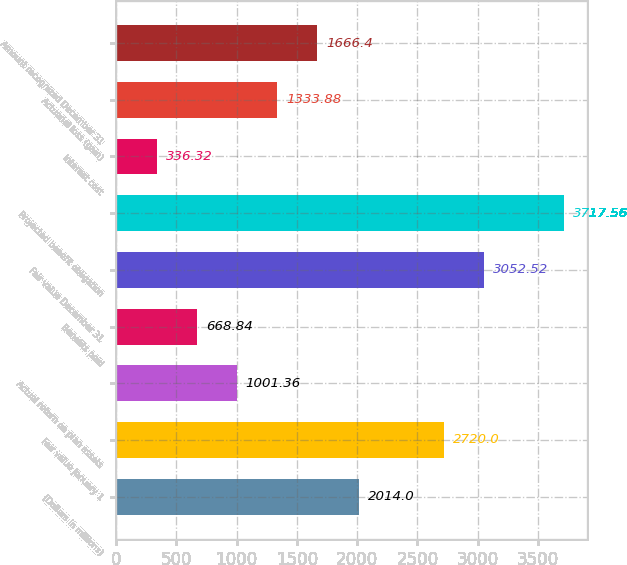<chart> <loc_0><loc_0><loc_500><loc_500><bar_chart><fcel>(Dollars in millions)<fcel>Fair value January 1<fcel>Actual return on plan assets<fcel>Benefits paid<fcel>Fair value December 31<fcel>Projected benefit obligation<fcel>Interest cost<fcel>Actuarial loss (gain)<fcel>Amount recognized December 31<nl><fcel>2014<fcel>2720<fcel>1001.36<fcel>668.84<fcel>3052.52<fcel>3717.56<fcel>336.32<fcel>1333.88<fcel>1666.4<nl></chart> 